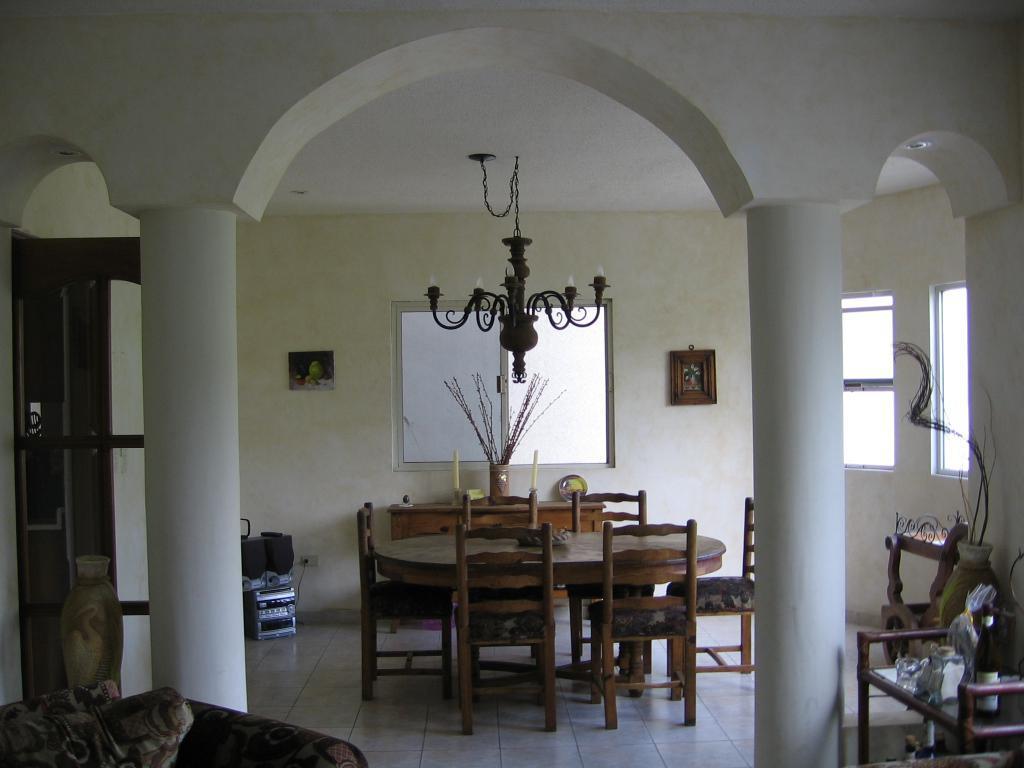Describe this image in one or two sentences. In the foreground I can see a table, chairs, sofa, photo frames on a wall, pillars, windows and a door. At the top, I can see a chandelier and flower pots. This image is taken may be in a room. 